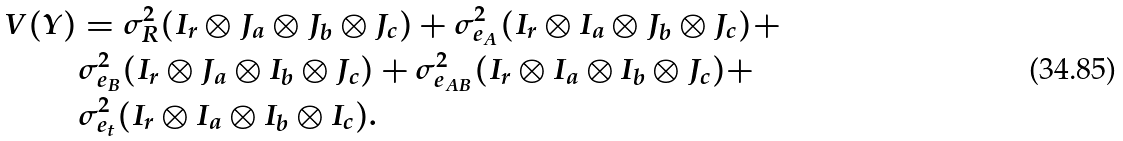<formula> <loc_0><loc_0><loc_500><loc_500>V ( Y ) & = \sigma _ { R } ^ { 2 } ( I _ { r } \otimes J _ { a } \otimes J _ { b } \otimes J _ { c } ) + \sigma _ { e _ { A } } ^ { 2 } ( I _ { r } \otimes I _ { a } \otimes J _ { b } \otimes J _ { c } ) + \\ & \sigma _ { e _ { B } } ^ { 2 } ( I _ { r } \otimes J _ { a } \otimes I _ { b } \otimes J _ { c } ) + \sigma _ { e _ { A B } } ^ { 2 } ( I _ { r } \otimes I _ { a } \otimes I _ { b } \otimes J _ { c } ) + \\ & \sigma _ { e _ { t } } ^ { 2 } ( I _ { r } \otimes I _ { a } \otimes I _ { b } \otimes I _ { c } ) .</formula> 